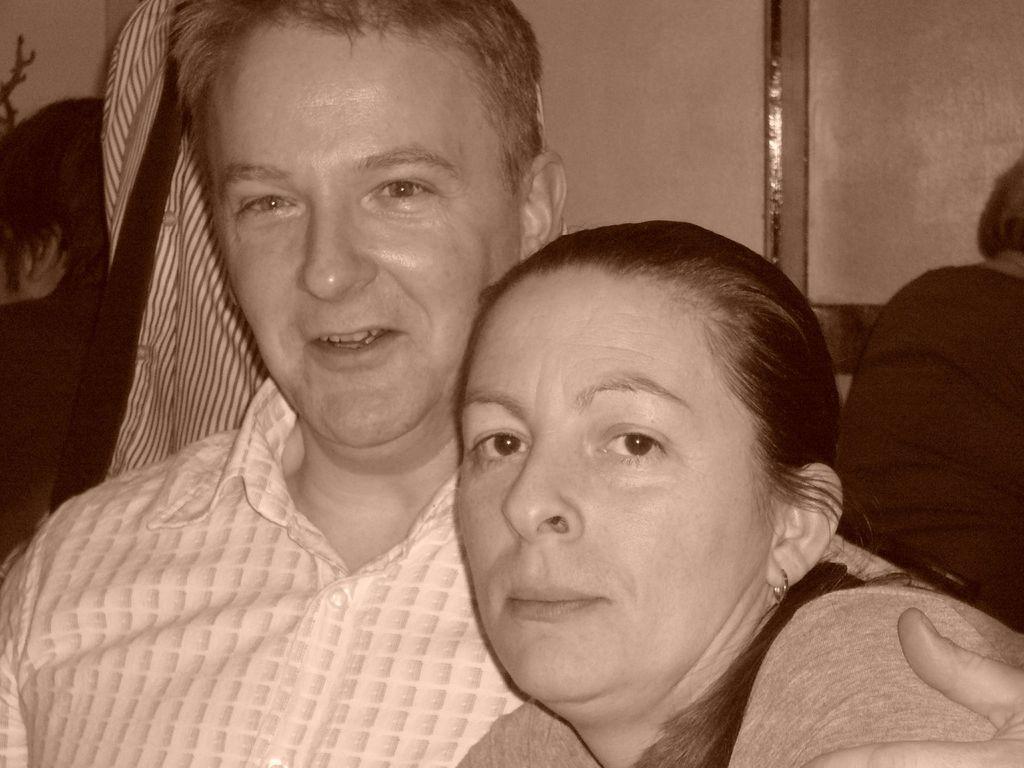Please provide a concise description of this image. In this image I can see 2 people. There is another person on the right. 